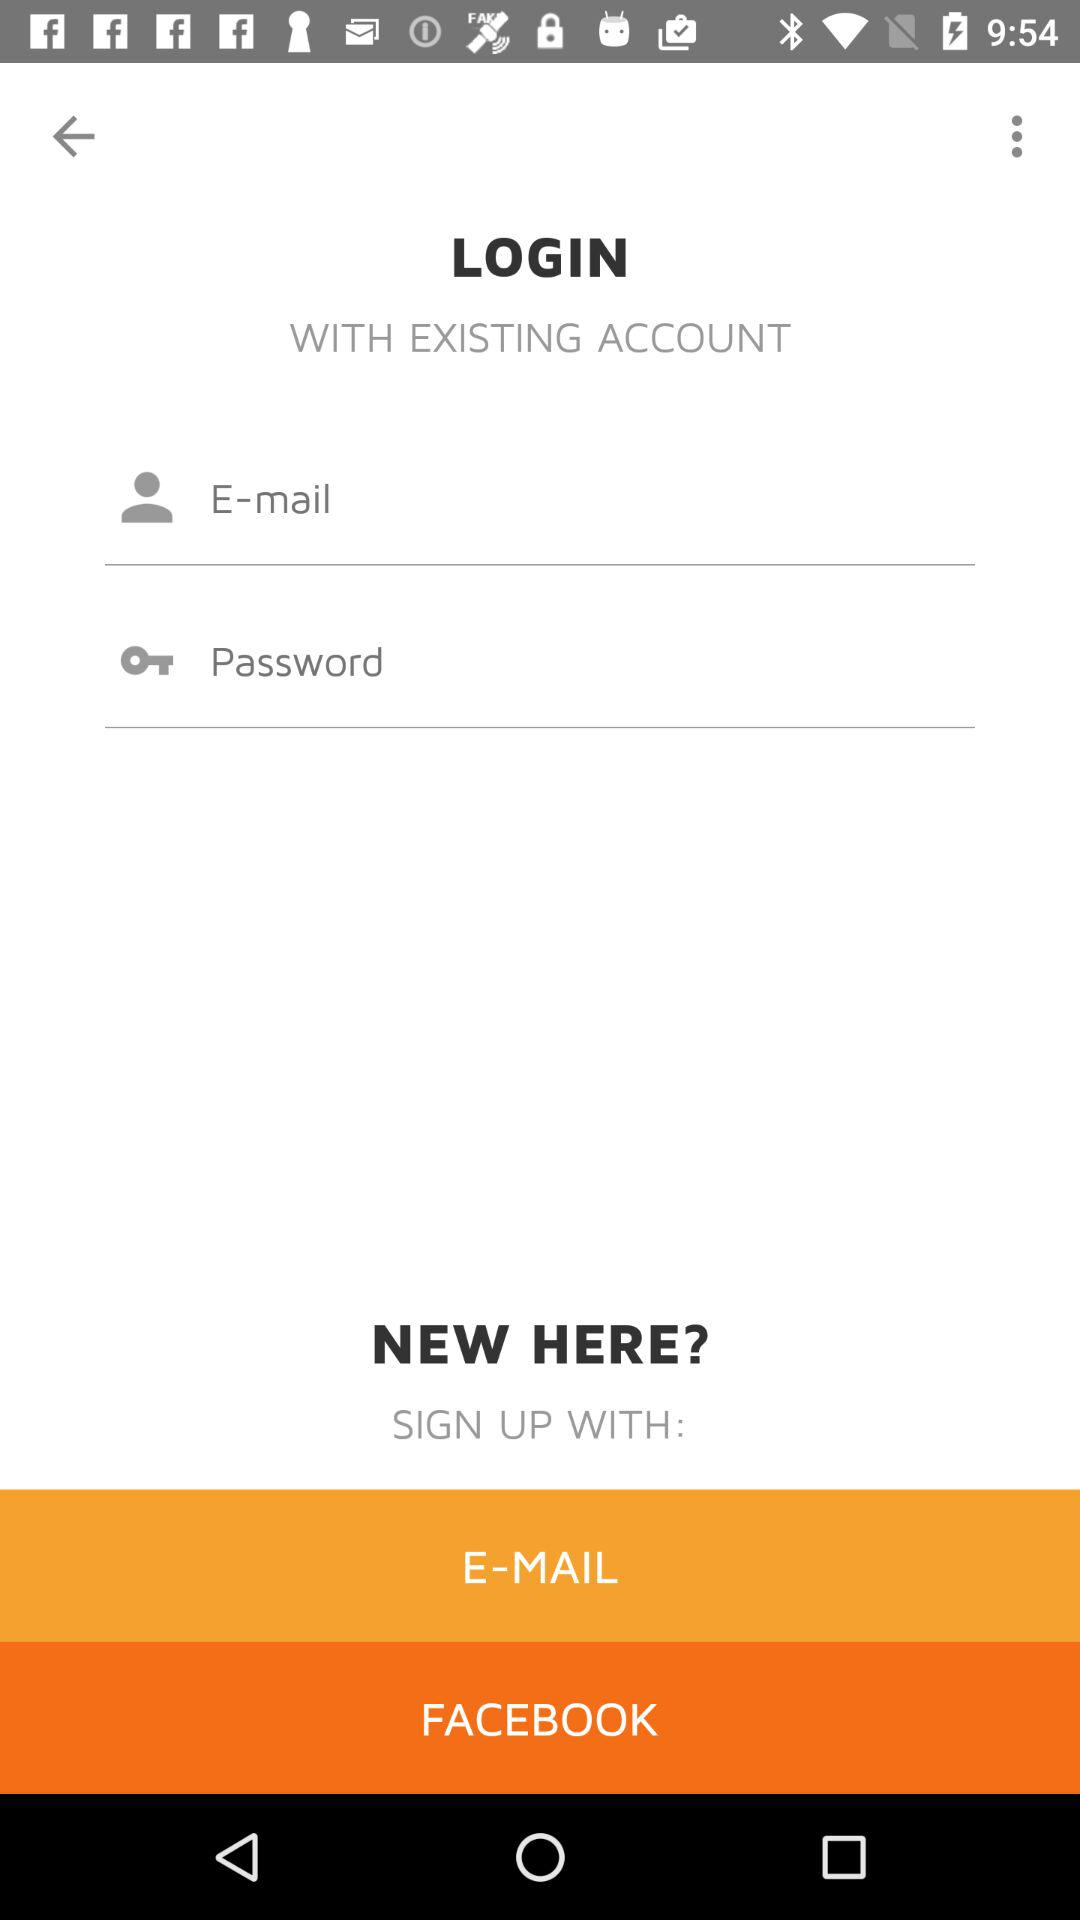How many login methods are available?
Answer the question using a single word or phrase. 2 